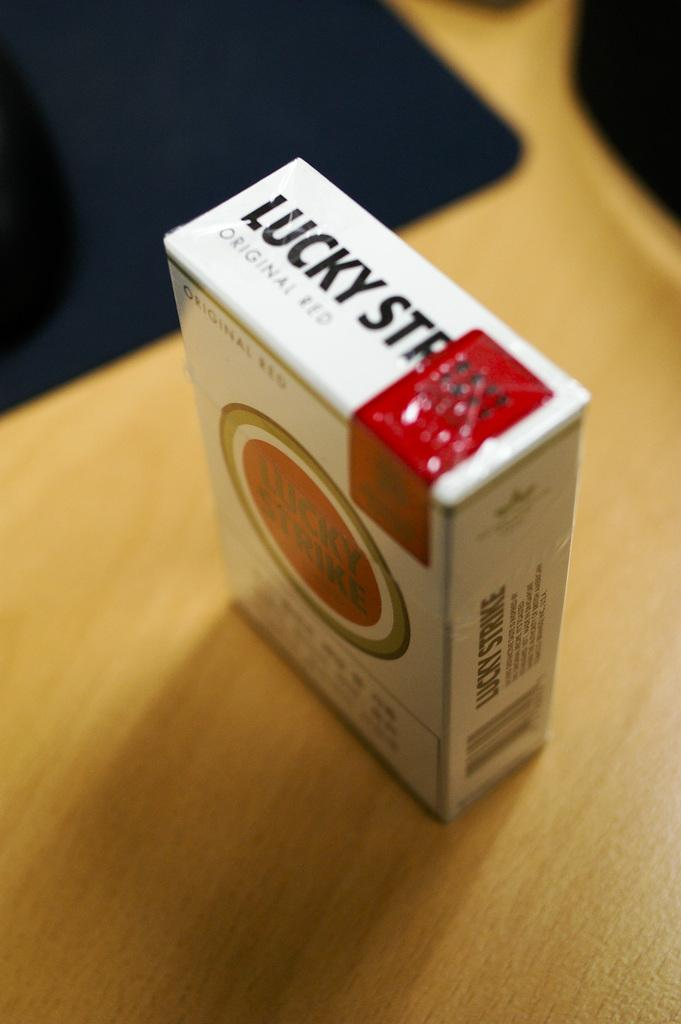<image>
Provide a brief description of the given image. The pack of cigarette on the counter is a pack of Luck Strikes Original Red. 